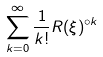<formula> <loc_0><loc_0><loc_500><loc_500>\sum _ { k = 0 } ^ { \infty } \frac { 1 } { k ! } R ( \xi ) ^ { \circ k }</formula> 